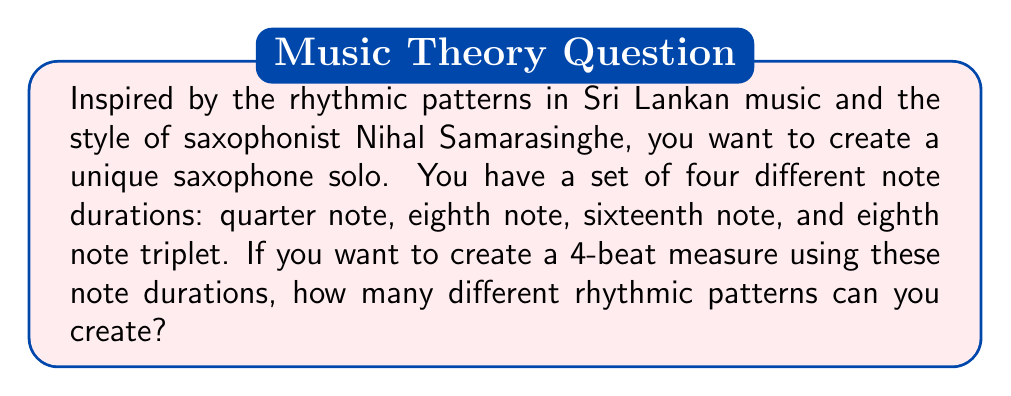Help me with this question. Let's approach this step-by-step:

1) First, we need to understand how many of each note duration fit into a 4-beat measure:
   - Quarter note (1/4): 4
   - Eighth note (1/8): 8
   - Sixteenth note (1/16): 16
   - Eighth note triplet (1/12): 12

2) This is a combination with repetition problem. We can use any of these notes multiple times to fill the 4-beat measure.

3) We can think of this as filling 16 sixteenth-note slots, where:
   - A quarter note fills 4 slots
   - An eighth note fills 2 slots
   - A sixteenth note fills 1 slot
   - An eighth note triplet fills 1.33 slots (rounded to 1 for simplicity)

4) The number of ways to fill these 16 slots with our 4 types of notes is given by the stars and bars formula:

   $$\binom{n+k-1}{k-1}$$

   Where $n$ is the number of slots (16) and $k$ is the number of types of notes (4).

5) Plugging in our values:

   $$\binom{16+4-1}{4-1} = \binom{19}{3}$$

6) We can calculate this as:

   $$\binom{19}{3} = \frac{19!}{3!(19-3)!} = \frac{19!}{3!16!} = \frac{19 \cdot 18 \cdot 17}{3 \cdot 2 \cdot 1} = 969$$

Therefore, there are 969 different rhythmic patterns possible.
Answer: 969 different rhythmic patterns 